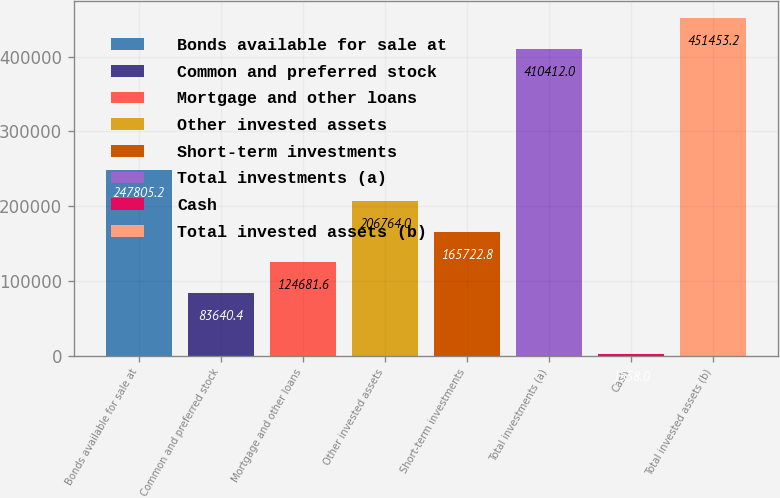Convert chart to OTSL. <chart><loc_0><loc_0><loc_500><loc_500><bar_chart><fcel>Bonds available for sale at<fcel>Common and preferred stock<fcel>Mortgage and other loans<fcel>Other invested assets<fcel>Short-term investments<fcel>Total investments (a)<fcel>Cash<fcel>Total invested assets (b)<nl><fcel>247805<fcel>83640.4<fcel>124682<fcel>206764<fcel>165723<fcel>410412<fcel>1558<fcel>451453<nl></chart> 